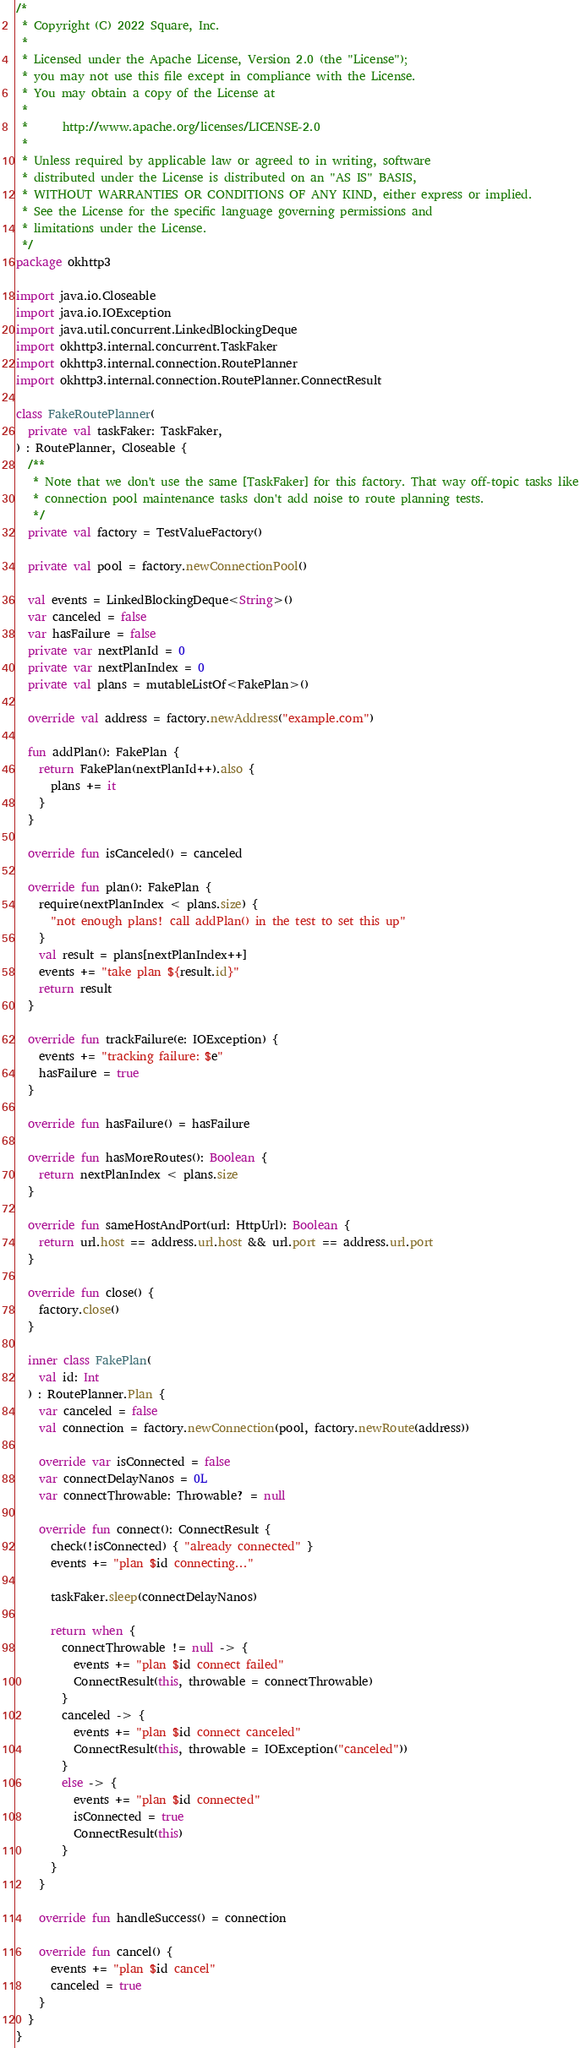<code> <loc_0><loc_0><loc_500><loc_500><_Kotlin_>/*
 * Copyright (C) 2022 Square, Inc.
 *
 * Licensed under the Apache License, Version 2.0 (the "License");
 * you may not use this file except in compliance with the License.
 * You may obtain a copy of the License at
 *
 *      http://www.apache.org/licenses/LICENSE-2.0
 *
 * Unless required by applicable law or agreed to in writing, software
 * distributed under the License is distributed on an "AS IS" BASIS,
 * WITHOUT WARRANTIES OR CONDITIONS OF ANY KIND, either express or implied.
 * See the License for the specific language governing permissions and
 * limitations under the License.
 */
package okhttp3

import java.io.Closeable
import java.io.IOException
import java.util.concurrent.LinkedBlockingDeque
import okhttp3.internal.concurrent.TaskFaker
import okhttp3.internal.connection.RoutePlanner
import okhttp3.internal.connection.RoutePlanner.ConnectResult

class FakeRoutePlanner(
  private val taskFaker: TaskFaker,
) : RoutePlanner, Closeable {
  /**
   * Note that we don't use the same [TaskFaker] for this factory. That way off-topic tasks like
   * connection pool maintenance tasks don't add noise to route planning tests.
   */
  private val factory = TestValueFactory()

  private val pool = factory.newConnectionPool()

  val events = LinkedBlockingDeque<String>()
  var canceled = false
  var hasFailure = false
  private var nextPlanId = 0
  private var nextPlanIndex = 0
  private val plans = mutableListOf<FakePlan>()

  override val address = factory.newAddress("example.com")

  fun addPlan(): FakePlan {
    return FakePlan(nextPlanId++).also {
      plans += it
    }
  }

  override fun isCanceled() = canceled

  override fun plan(): FakePlan {
    require(nextPlanIndex < plans.size) {
      "not enough plans! call addPlan() in the test to set this up"
    }
    val result = plans[nextPlanIndex++]
    events += "take plan ${result.id}"
    return result
  }

  override fun trackFailure(e: IOException) {
    events += "tracking failure: $e"
    hasFailure = true
  }

  override fun hasFailure() = hasFailure

  override fun hasMoreRoutes(): Boolean {
    return nextPlanIndex < plans.size
  }

  override fun sameHostAndPort(url: HttpUrl): Boolean {
    return url.host == address.url.host && url.port == address.url.port
  }

  override fun close() {
    factory.close()
  }

  inner class FakePlan(
    val id: Int
  ) : RoutePlanner.Plan {
    var canceled = false
    val connection = factory.newConnection(pool, factory.newRoute(address))

    override var isConnected = false
    var connectDelayNanos = 0L
    var connectThrowable: Throwable? = null

    override fun connect(): ConnectResult {
      check(!isConnected) { "already connected" }
      events += "plan $id connecting..."

      taskFaker.sleep(connectDelayNanos)

      return when {
        connectThrowable != null -> {
          events += "plan $id connect failed"
          ConnectResult(this, throwable = connectThrowable)
        }
        canceled -> {
          events += "plan $id connect canceled"
          ConnectResult(this, throwable = IOException("canceled"))
        }
        else -> {
          events += "plan $id connected"
          isConnected = true
          ConnectResult(this)
        }
      }
    }

    override fun handleSuccess() = connection

    override fun cancel() {
      events += "plan $id cancel"
      canceled = true
    }
  }
}
</code> 